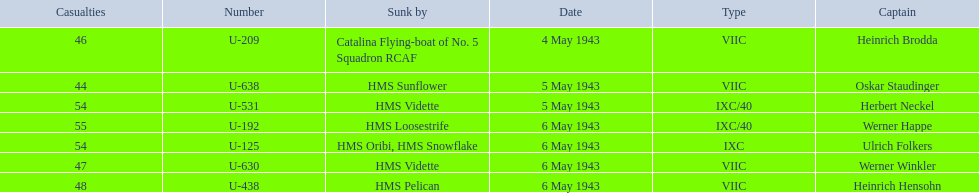What is the list of ships under sunk by? Catalina Flying-boat of No. 5 Squadron RCAF, HMS Sunflower, HMS Vidette, HMS Loosestrife, HMS Oribi, HMS Snowflake, HMS Vidette, HMS Pelican. Which captains did hms pelican sink? Heinrich Hensohn. 